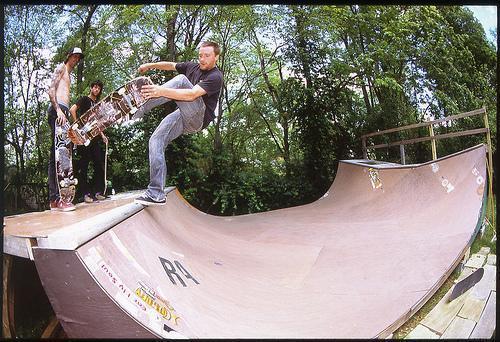How many people are skateboarding?
Give a very brief answer. 1. 